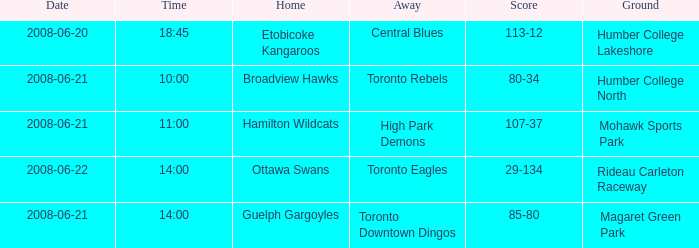When is the date for a home that is related to the hamilton wildcats? 2008-06-21. 